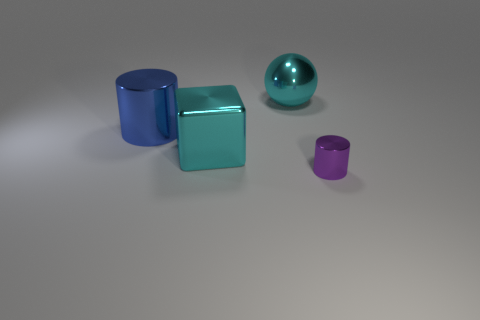Is there anything else that has the same size as the purple cylinder?
Provide a short and direct response. No. Are there any things that are on the left side of the shiny thing that is right of the big cyan metallic ball?
Give a very brief answer. Yes. There is a big thing that is on the right side of the shiny block; what is its shape?
Your answer should be compact. Sphere. There is a object that is the same color as the shiny block; what is it made of?
Your answer should be compact. Metal. The big thing that is in front of the big blue metal thing that is on the left side of the large cyan cube is what color?
Make the answer very short. Cyan. Does the blue cylinder have the same size as the purple shiny object?
Provide a short and direct response. No. How many cyan shiny cubes have the same size as the cyan ball?
Your answer should be compact. 1. The large ball that is the same material as the tiny cylinder is what color?
Your answer should be compact. Cyan. Are there fewer purple metallic objects than tiny green metal objects?
Make the answer very short. No. How many yellow things are metallic cubes or metallic balls?
Offer a very short reply. 0. 